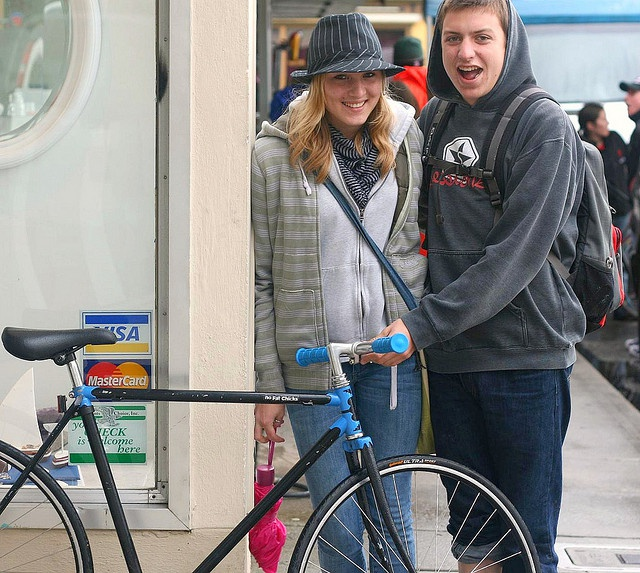Describe the objects in this image and their specific colors. I can see bicycle in tan, black, darkgray, gray, and lightgray tones, people in tan, black, gray, navy, and darkblue tones, people in tan, gray, darkgray, lightgray, and black tones, backpack in tan, black, gray, darkgray, and lightgray tones, and handbag in tan, black, gray, blue, and darkgreen tones in this image. 